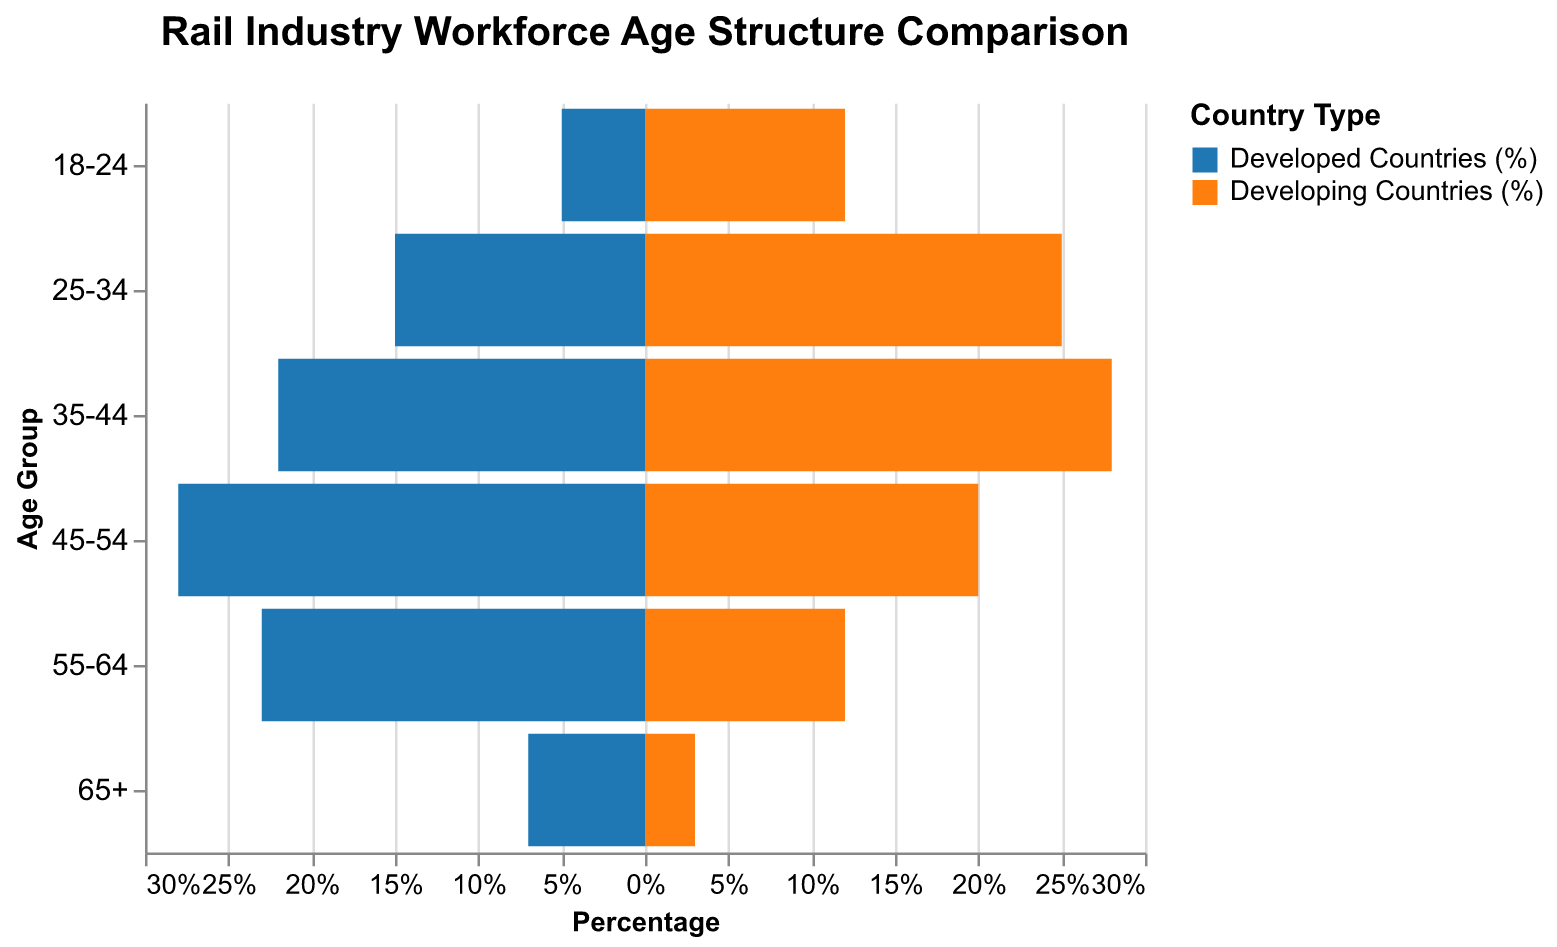What's the title of the figure? The title of the figure is displayed at the top and usually indicates the main topic of the chart.
Answer: Rail Industry Workforce Age Structure Comparison Which age group has the highest percentage in developed countries? By looking at the left side of the pyramid, observe the bar with the greatest magnitude.
Answer: 45-54 What is the percentage difference between 25-34 age group in developed and developing countries? Subtract the percentage of developed countries from that of developing countries for the 25-34 age group.
Answer: 10% Which country type has a higher percentage of workers aged 55-64? Compare the lengths of the bars for the 55-64 age group on both sides of the pyramid.
Answer: Developed countries What's the combined percentage of workers aged 18-24 and 25-34 in developing countries? Add the percentages of the developing countries for 18-24 and 25-34 age groups.
Answer: 37% In which country type do we see a higher overall percentage of younger workers (18-34)? Add the percentages for the 18-24 and 25-34 age groups in both country types and compare.
Answer: Developing countries How does the percentage of 65+ workers in developed countries compare to developing countries? Look at the bars for the 65+ age group and compare their magnitudes.
Answer: More in developed countries What is the average percentage of workers aged 35-44 in both developed and developing countries? Calculate the average of the given percentages for this age group in both country types: (22% + 28%) / 2.
Answer: 25% Which age group has a more balanced workforce distribution between developed and developing countries? Identify the age group where the percentage difference between both country types is minimal.
Answer: 45-54 What's the sum of all percentages for workers aged 45-54 and 55-64 in developed countries? Add the percentages for these age groups in developed countries: 28% + 23%.
Answer: 51% 